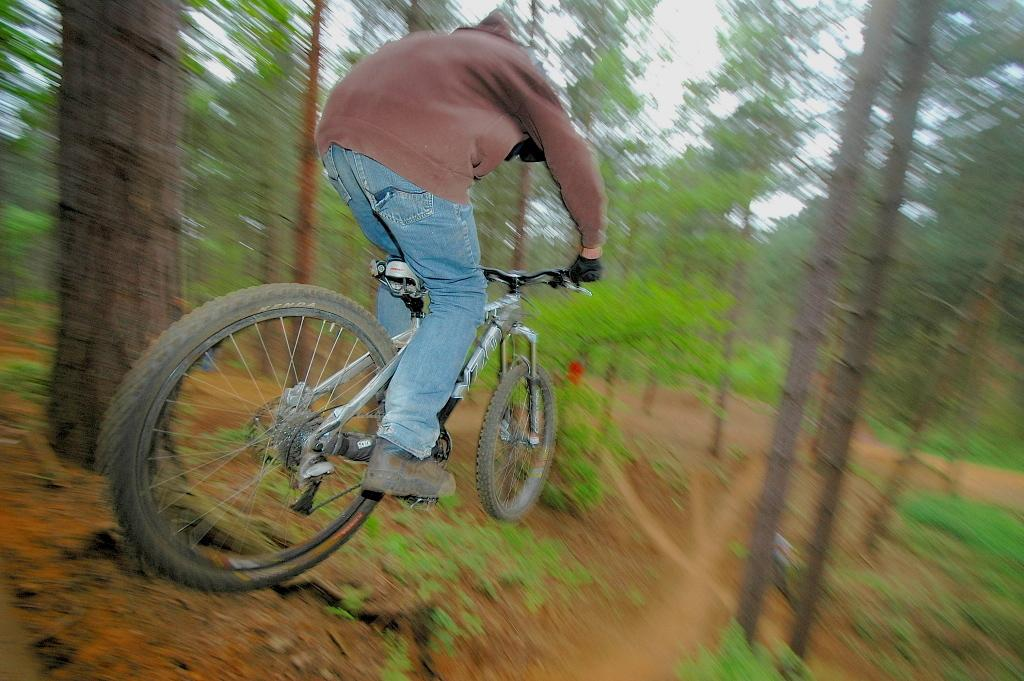Who or what is the main subject in the image? There is a person in the image. What is the person wearing? The person is wearing a brown color sweatshirt. What activity is the person engaged in? The person is riding a bicycle. What can be seen in the background of the image? There are trees in the background of the image. What type of truck can be seen in the image? There is no truck present in the image. Is there a crib visible in the image? There is no crib present in the image. 